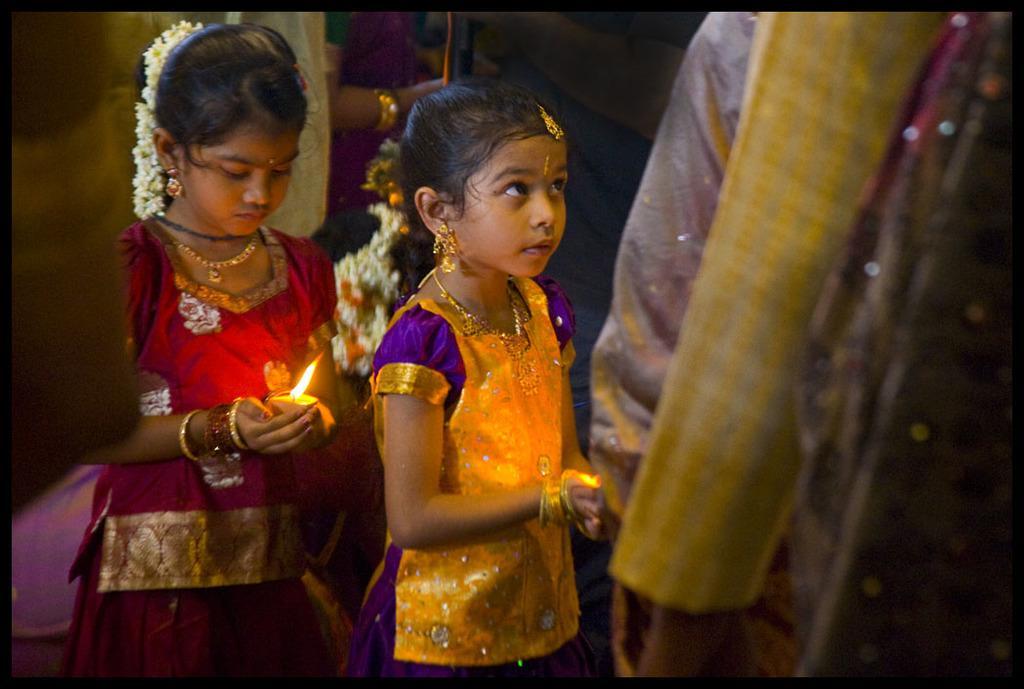In one or two sentences, can you explain what this image depicts? In this image I can see there are two girls they both are wearing colorful dresses and holding candles on their hand and I can see a person hand visible on the right side and at the top I can see a person. 